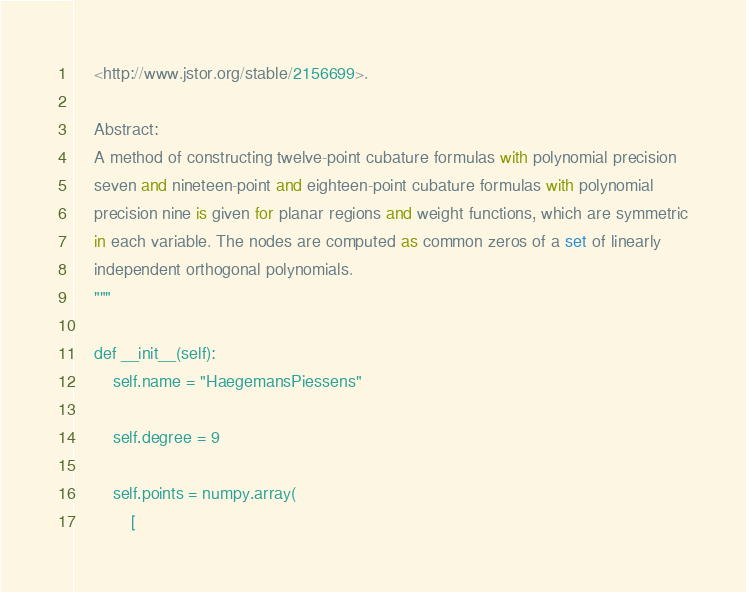<code> <loc_0><loc_0><loc_500><loc_500><_Python_>    <http://www.jstor.org/stable/2156699>.

    Abstract:
    A method of constructing twelve-point cubature formulas with polynomial precision
    seven and nineteen-point and eighteen-point cubature formulas with polynomial
    precision nine is given for planar regions and weight functions, which are symmetric
    in each variable. The nodes are computed as common zeros of a set of linearly
    independent orthogonal polynomials.
    """

    def __init__(self):
        self.name = "HaegemansPiessens"

        self.degree = 9

        self.points = numpy.array(
            [</code> 